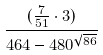<formula> <loc_0><loc_0><loc_500><loc_500>\frac { ( \frac { 7 } { 5 1 } \cdot 3 ) } { 4 6 4 - 4 8 0 ^ { \sqrt { 8 6 } } }</formula> 